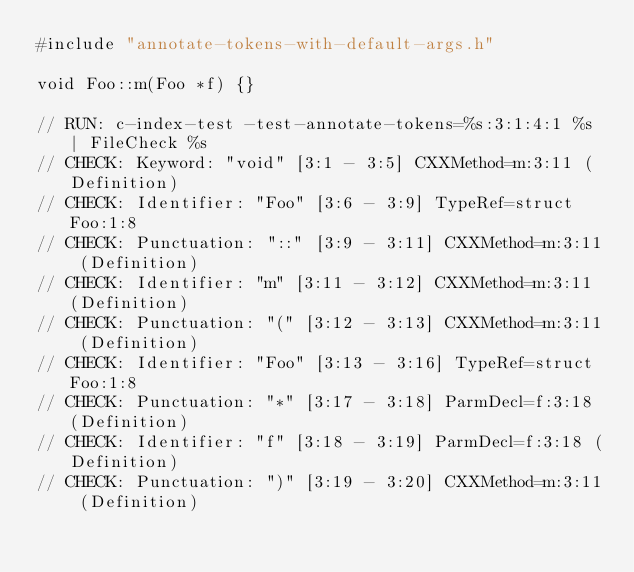Convert code to text. <code><loc_0><loc_0><loc_500><loc_500><_C++_>#include "annotate-tokens-with-default-args.h"

void Foo::m(Foo *f) {}

// RUN: c-index-test -test-annotate-tokens=%s:3:1:4:1 %s | FileCheck %s
// CHECK: Keyword: "void" [3:1 - 3:5] CXXMethod=m:3:11 (Definition)
// CHECK: Identifier: "Foo" [3:6 - 3:9] TypeRef=struct Foo:1:8
// CHECK: Punctuation: "::" [3:9 - 3:11] CXXMethod=m:3:11 (Definition)
// CHECK: Identifier: "m" [3:11 - 3:12] CXXMethod=m:3:11 (Definition)
// CHECK: Punctuation: "(" [3:12 - 3:13] CXXMethod=m:3:11 (Definition)
// CHECK: Identifier: "Foo" [3:13 - 3:16] TypeRef=struct Foo:1:8
// CHECK: Punctuation: "*" [3:17 - 3:18] ParmDecl=f:3:18 (Definition)
// CHECK: Identifier: "f" [3:18 - 3:19] ParmDecl=f:3:18 (Definition)
// CHECK: Punctuation: ")" [3:19 - 3:20] CXXMethod=m:3:11 (Definition)</code> 